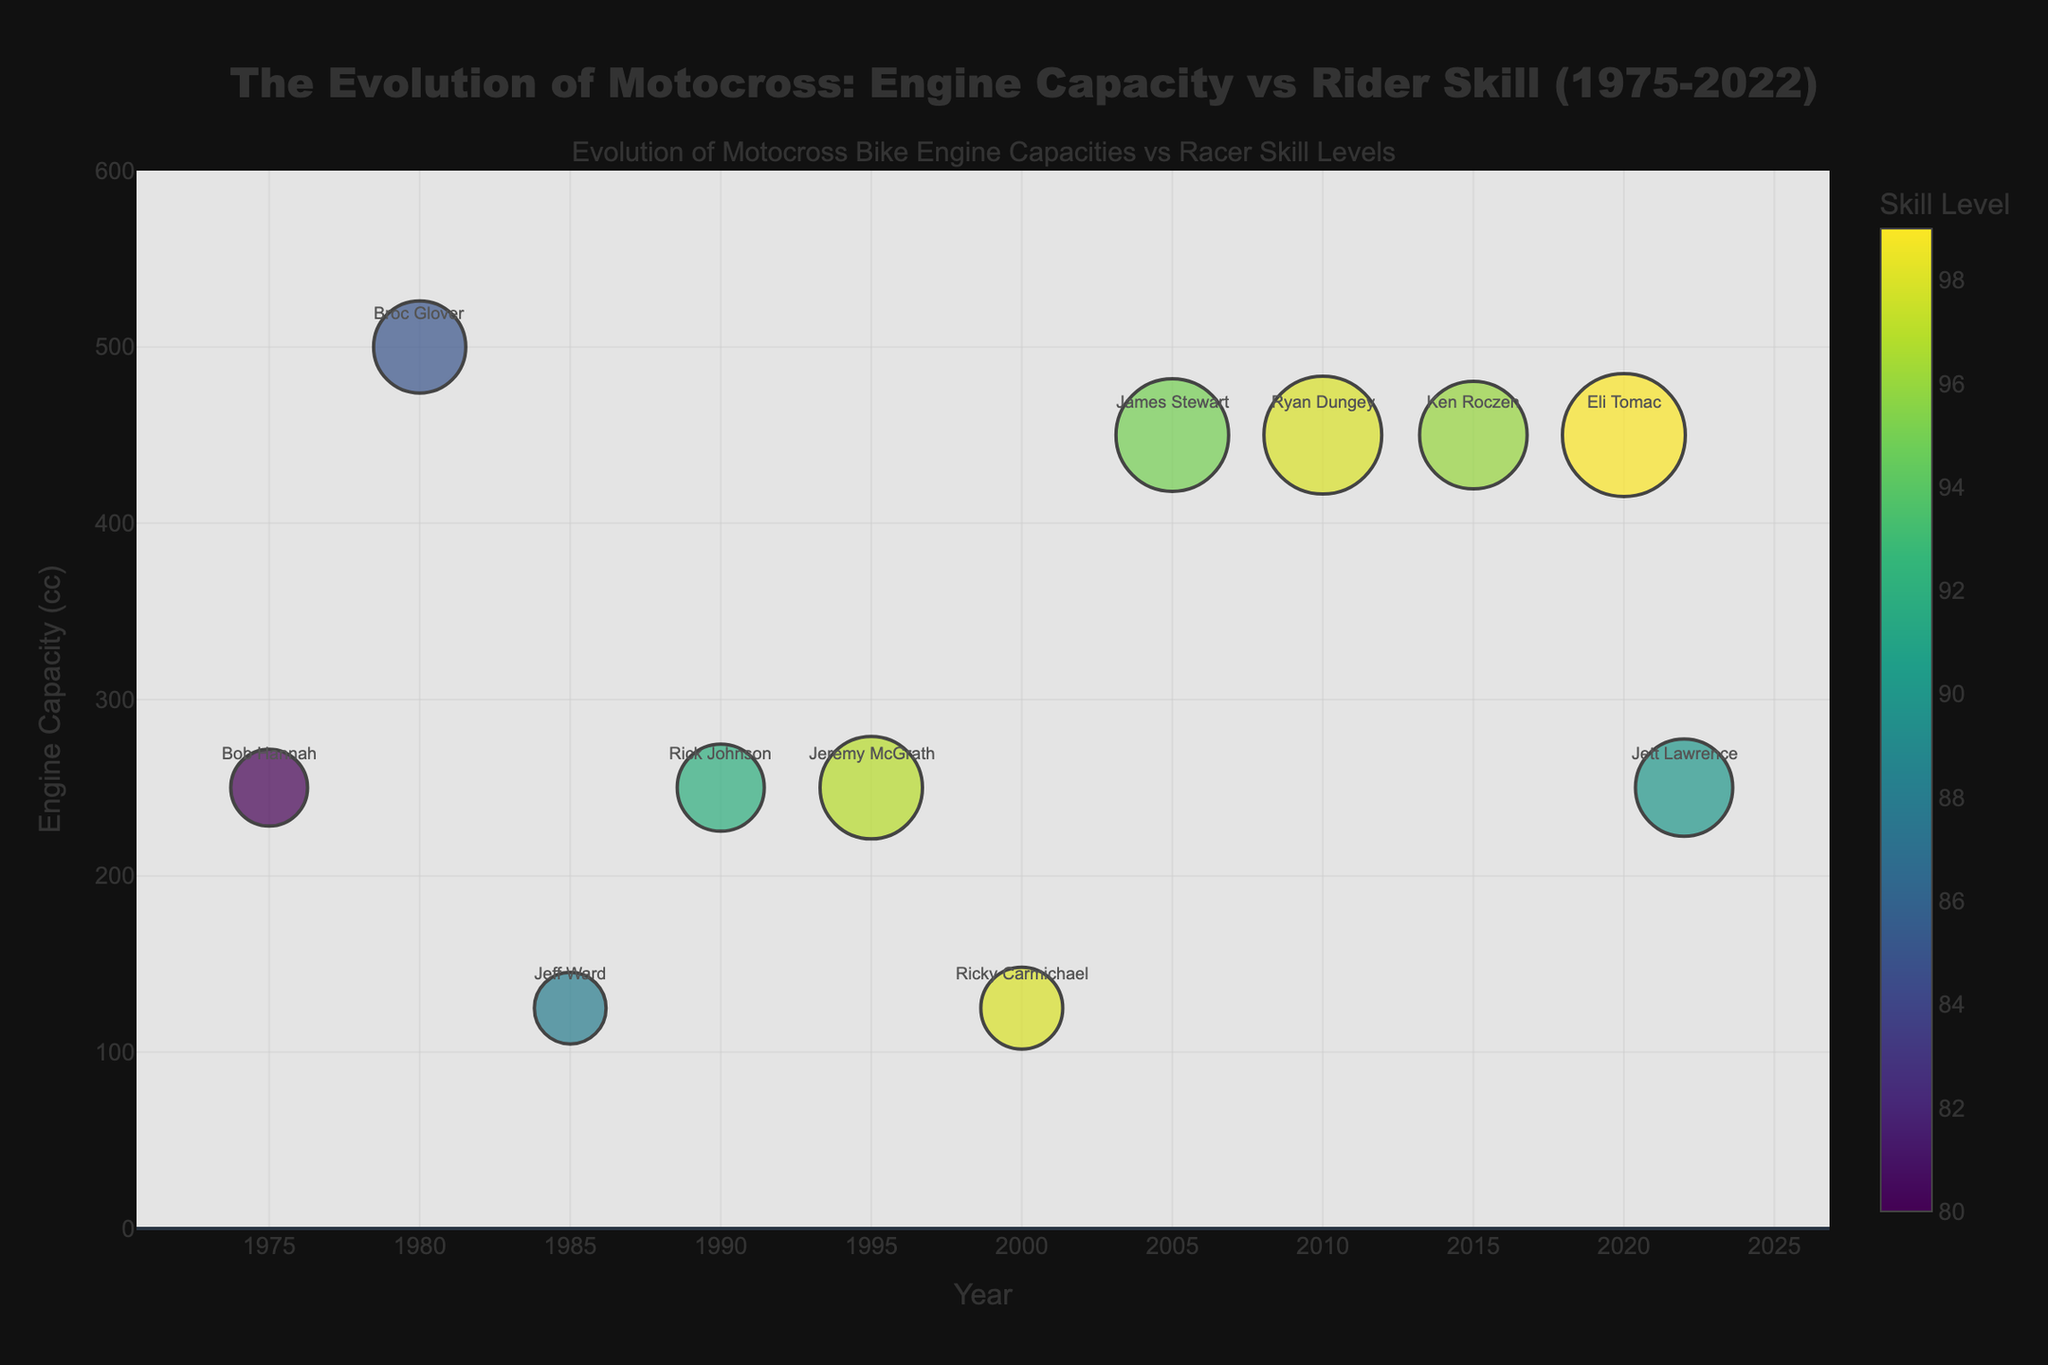What title is displayed in the figure? The figure has a prominent title at the top. By reading the title, one can understand the overall theme or purpose of the chart.
Answer: The Evolution of Motocross: Engine Capacity vs Rider Skill (1975-2022) What is the skill level of the racer with the largest engine capacity? Identify the bubble corresponding to the largest engine capacity on the y-axis. The tooltip or color bar will indicate the skill level.
Answer: 95 How many racers have engine capacities of 450cc? Count all the bubbles that have an engine capacity of 450cc along the y-axis.
Answer: Four Who appears to have the highest skill level and in what year did they race? Look for the deepest color on the colorscale indicating the highest skill level and check the associated year.
Answer: Eli Tomac, 2020 Between 1975 and 1990, which racer had the highest skill level? Isolate the bubbles from 1975 to 1990 on the x-axis and compare their colors for the one with the highest skill level.
Answer: Rick Johnson Which racer in the year 2005 had what engine capacity and skill level? Locate the bubble corresponding to the year 2005 and observe the y-axis for engine capacity and color for skill level.
Answer: James Stewart, 450cc, 95 What's the average engine capacity of all the racers listed in the figure? Sum all the engine capacities listed and divide by the total number of racers to find the average. (250 + 500 + 125 + 250 + 250 + 125 + 450 + 450 + 450 + 450 + 250 = 4000. Average = 4000/11)
Answer: 363.64 Which year experienced the highest concentration of elite skill levels (95 and above)? Check all the years and count the number of racers with skill levels 95 and above, then identify the year with the highest count.
Answer: 2010 What is the difference in skill level between Bob Hannah and Jett Lawrence? Compare Bob Hannah's skill level and Jett Lawrence's skill level and calculate the difference. (90 - 80)
Answer: 10 